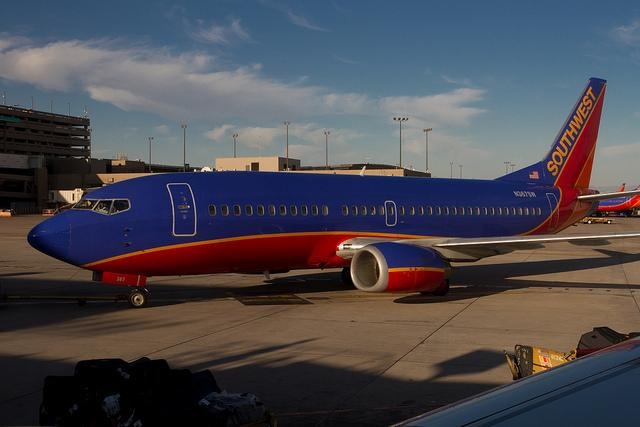What is the blue plane used for? transportation 